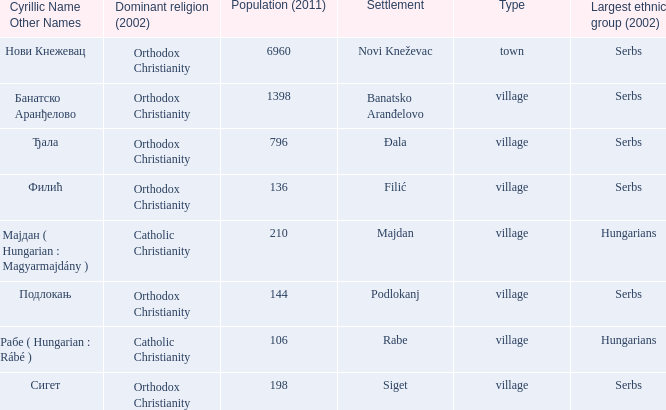How many dominant religions are in đala? 1.0. 